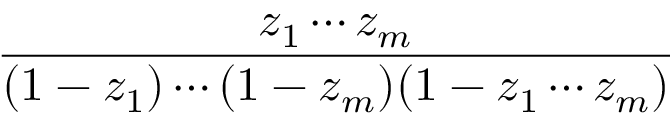Convert formula to latex. <formula><loc_0><loc_0><loc_500><loc_500>\frac { z _ { 1 } \cdots z _ { m } } { ( 1 - z _ { 1 } ) \cdots ( 1 - z _ { m } ) ( 1 - z _ { 1 } \cdots z _ { m } ) }</formula> 